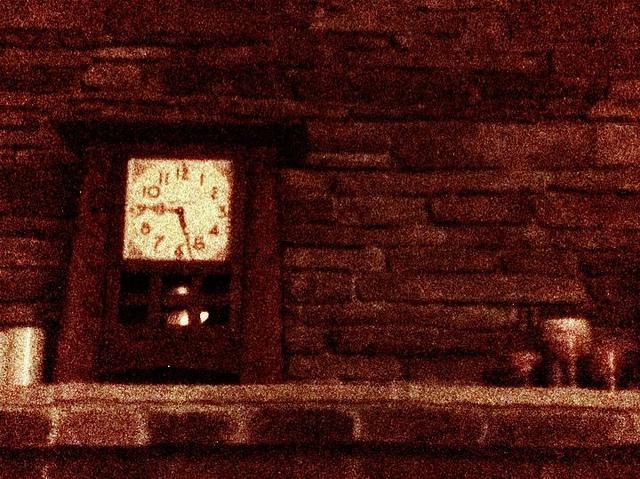What is on the mantle?
Answer briefly. Clock. Is the clock face square?
Keep it brief. Yes. What time is shown on the clock?
Answer briefly. 9:28. Is this photo too grainy to make out textures?
Give a very brief answer. Yes. 